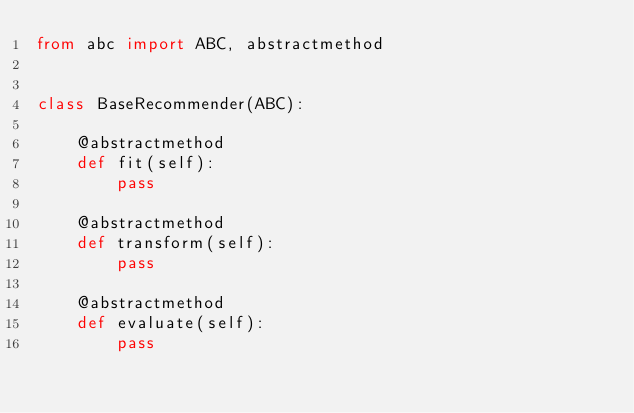<code> <loc_0><loc_0><loc_500><loc_500><_Python_>from abc import ABC, abstractmethod


class BaseRecommender(ABC):

    @abstractmethod
    def fit(self):
        pass

    @abstractmethod
    def transform(self):
        pass

    @abstractmethod
    def evaluate(self):
        pass
</code> 